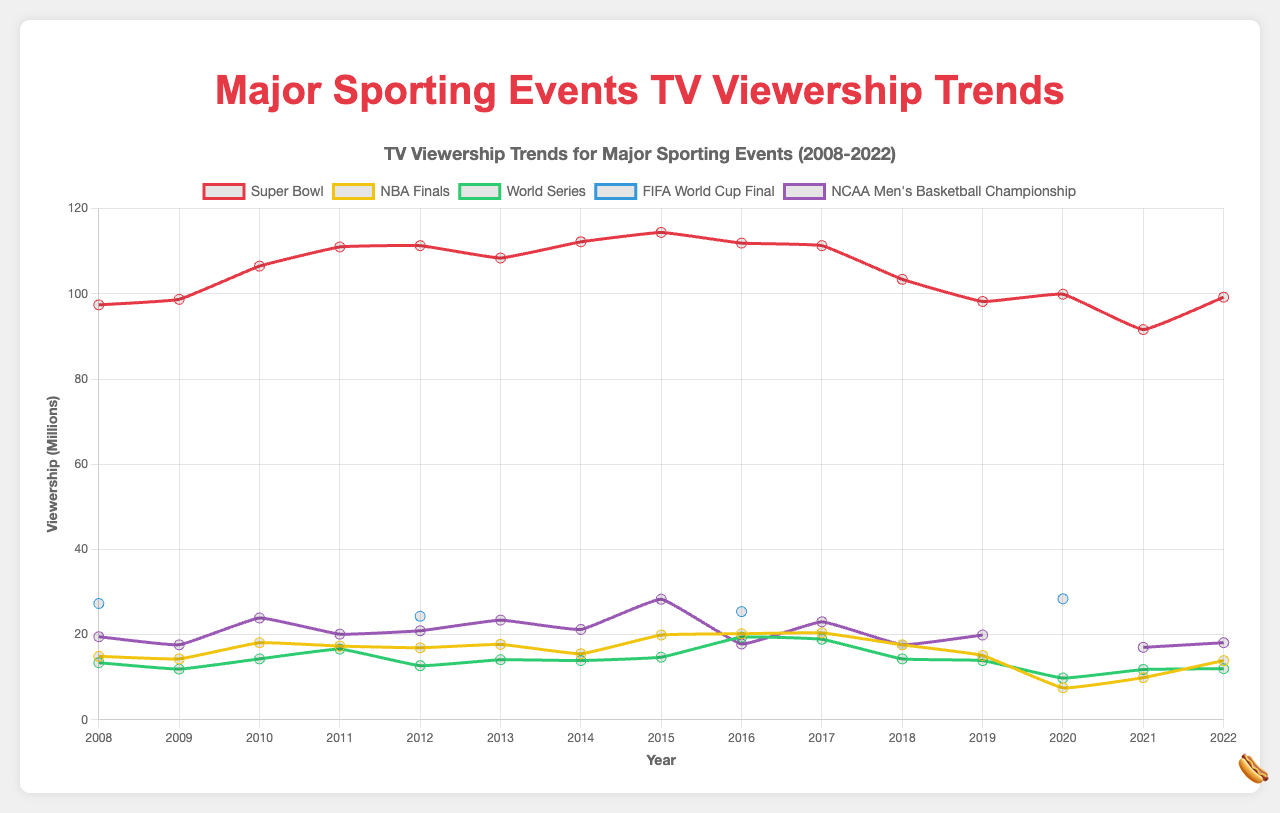what trend do you observe in the Super Bowl viewership from 2008 to 2022? Between 2008 and 2015, Super Bowl viewership generally increased, peaking in 2015. From 2016 onwards, there is a noticeable decline, dropping to a low point in 2021, before a slight increase in 2022.
Answer: Increasing trend till 2015, then declining which event had the highest recorded viewership in the given period? The event with the highest recorded viewership is the Super Bowl in 2015, with 114.4 million viewers. This can be identified by looking at the peak point in the Super Bowl's trend line.
Answer: Super Bowl 2015 how did the viewership for the NBA Finals change from 2019 to 2020? The viewership for the NBA Finals dropped significantly from 15.1 million in 2019 to 7.5 million in 2020, which is a sharp decline.
Answer: Sharp decline what is the average viewership of the World Series from 2015 to 2020? To find the average, sum the viewership numbers for these years (14.7 + 19.4 + 18.9 + 14.3 + 13.9 + 9.8) = 91, and divide by the number of years (6). The average viewership is 91/6 = 15.2 million.
Answer: 15.2 million compare the viewership trends of the NCAA Men's Basketball Championship and the FIFA World Cup Final The NCAA Men's Basketball Championship shows variable viewership with some peaks and troughs but has a visible dip in 2020. The FIFA World Cup Final has noticeable data only for the years it occurred but shows an increasing trend overall.
Answer: Variable for NCAA, Increasing for FIFA which year did the Super Bowl first see a decline in viewership after 2015? After 2015, the first year the Super Bowl saw a decline in viewership was 2016, where the viewership dropped from 114.4 million to 111.9 million.
Answer: 2016 which event has the least viewership in 2020, and what is its value? The NBA Finals had the least viewership in 2020, with 7.5 million viewers. This can be identified by looking at the lowest point for the year 2020 across all events.
Answer: NBA Finals 2020, 7.5 million what is the total viewership for the Super Bowl over the entire dataset? To find the total viewership, sum the values across all years for the Super Bowl (97.4 + 98.7 + 106.5 + 111.0 + 111.3 + 108.4 + 112.2 + 114.4 + 111.9 + 111.3 + 103.4 + 98.2 + 99.9 + 91.6 + 99.2) = 1574.4 million.
Answer: 1574.4 million how often does the FIFA World Cup Final occur, based on the data provided? The data shows viewership for the FIFA World Cup Final in 2008, 2012, 2016, and 2020, indicating it occurs every four years.
Answer: Every four years 